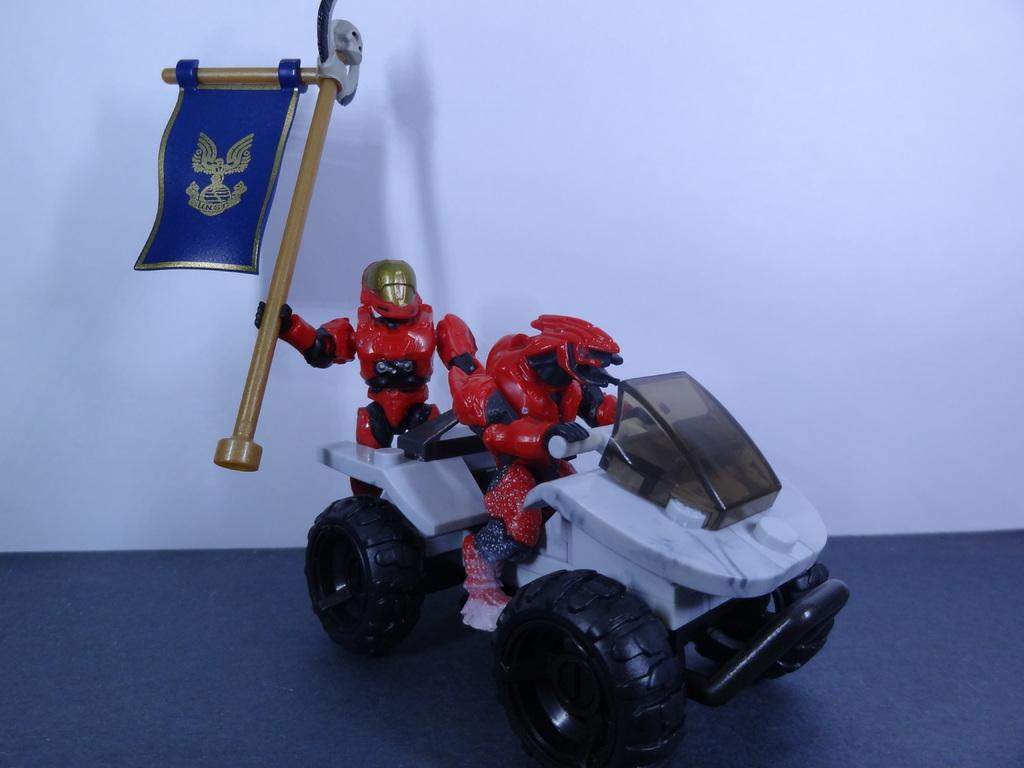What object is the main subject of the image? There is a toy in the image. Where is the toy located? The toy is on a platform. What color is the background of the image? The background of the image is white. What book is the person reading on the table in the image? There is no table, person, or book present in the image; it only features a toy on a platform with a white background. 